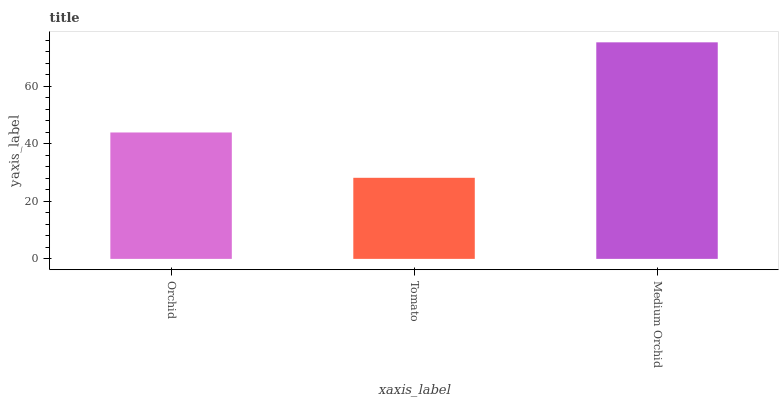Is Tomato the minimum?
Answer yes or no. Yes. Is Medium Orchid the maximum?
Answer yes or no. Yes. Is Medium Orchid the minimum?
Answer yes or no. No. Is Tomato the maximum?
Answer yes or no. No. Is Medium Orchid greater than Tomato?
Answer yes or no. Yes. Is Tomato less than Medium Orchid?
Answer yes or no. Yes. Is Tomato greater than Medium Orchid?
Answer yes or no. No. Is Medium Orchid less than Tomato?
Answer yes or no. No. Is Orchid the high median?
Answer yes or no. Yes. Is Orchid the low median?
Answer yes or no. Yes. Is Medium Orchid the high median?
Answer yes or no. No. Is Medium Orchid the low median?
Answer yes or no. No. 